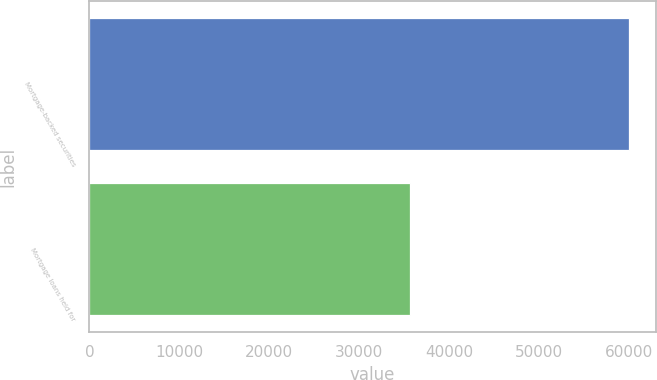<chart> <loc_0><loc_0><loc_500><loc_500><bar_chart><fcel>Mortgage-backed securities<fcel>Mortgage loans held for<nl><fcel>59975<fcel>35659<nl></chart> 